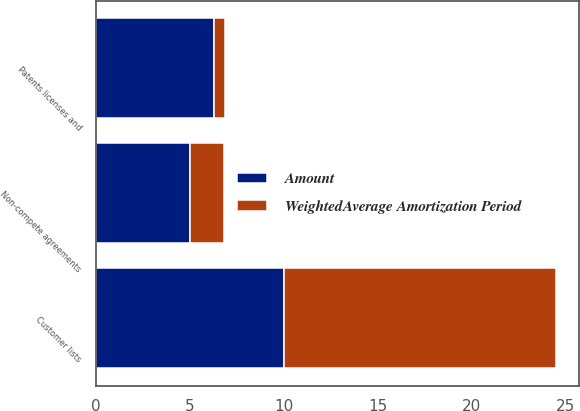Convert chart. <chart><loc_0><loc_0><loc_500><loc_500><stacked_bar_chart><ecel><fcel>Customer lists<fcel>Patents licenses and<fcel>Non-compete agreements<nl><fcel>WeightedAverage Amortization Period<fcel>14.5<fcel>0.6<fcel>1.8<nl><fcel>Amount<fcel>10<fcel>6.3<fcel>5<nl></chart> 